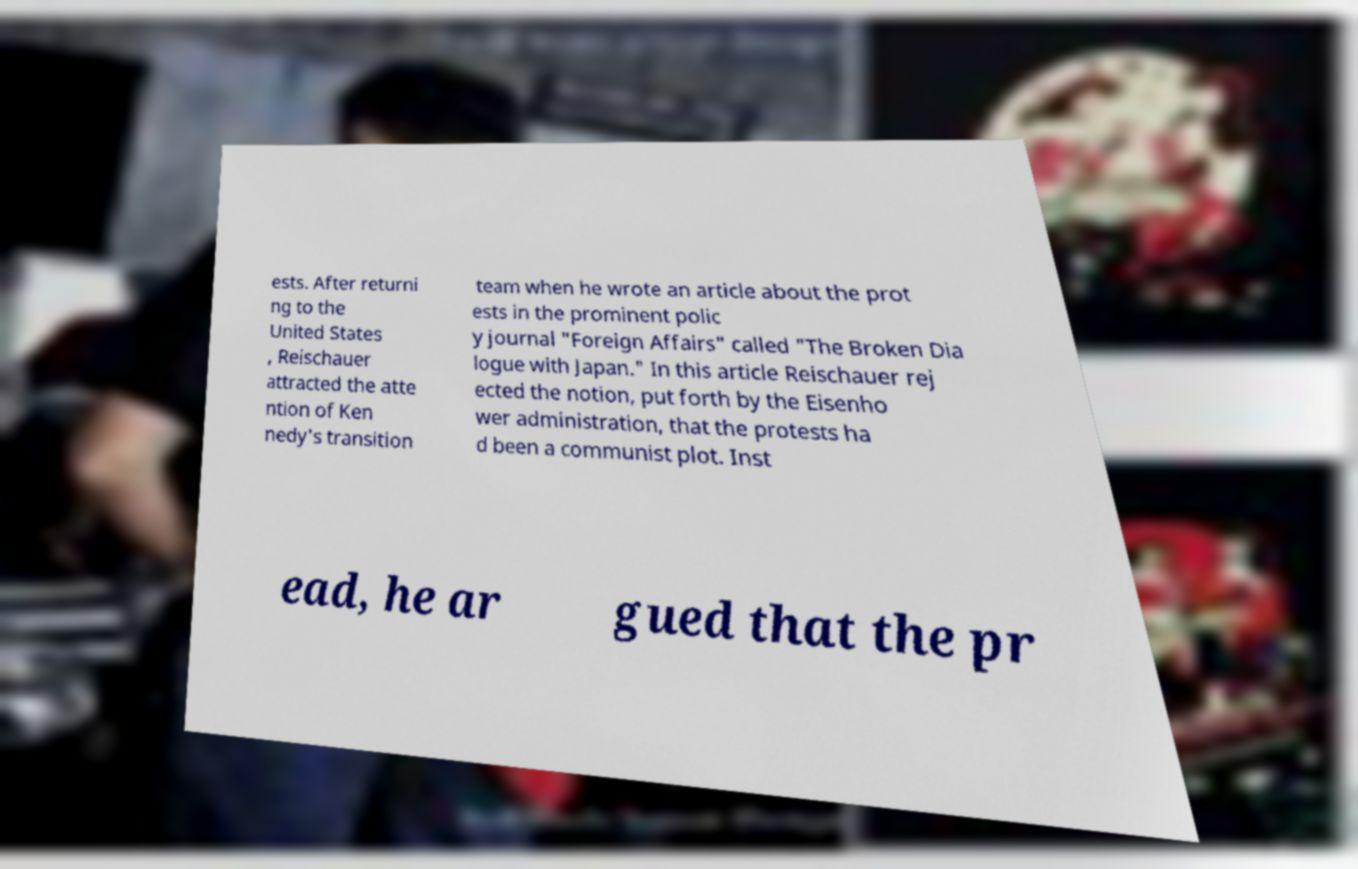Please read and relay the text visible in this image. What does it say? ests. After returni ng to the United States , Reischauer attracted the atte ntion of Ken nedy's transition team when he wrote an article about the prot ests in the prominent polic y journal "Foreign Affairs" called "The Broken Dia logue with Japan." In this article Reischauer rej ected the notion, put forth by the Eisenho wer administration, that the protests ha d been a communist plot. Inst ead, he ar gued that the pr 